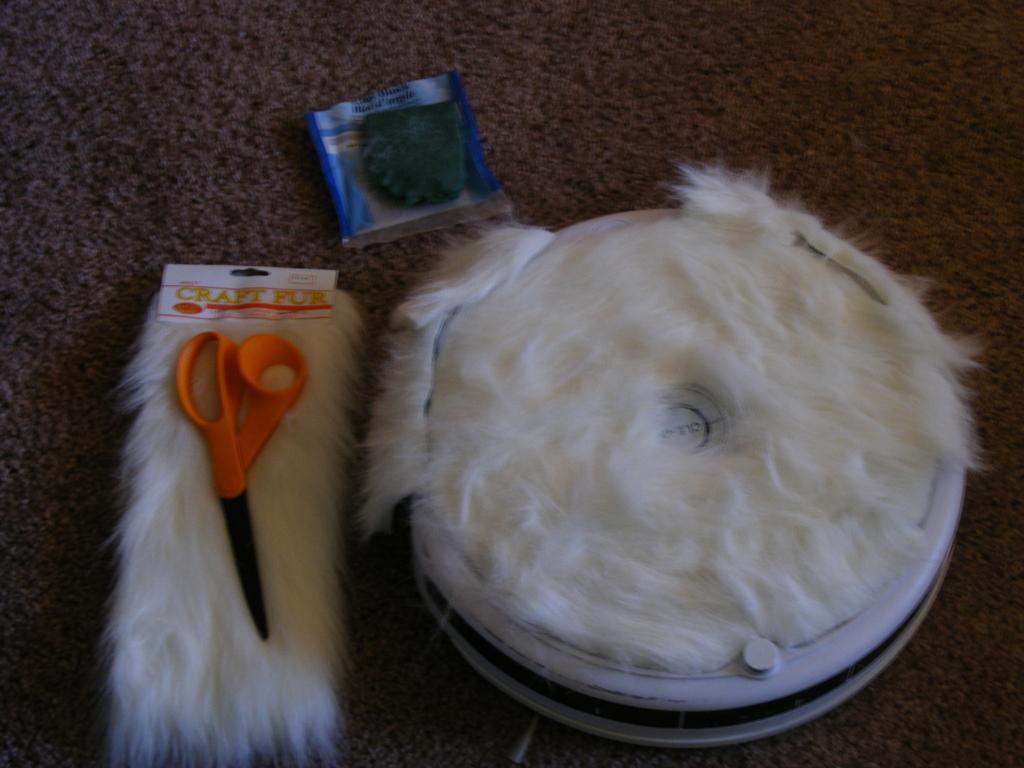Can you describe this image briefly? In this image there is a rectangular fur piece on which there is a scissor, beside that there is a round thing covered with fur also there is a small packet kept on the carpet. 